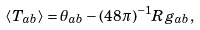<formula> <loc_0><loc_0><loc_500><loc_500>\langle T _ { a b } \rangle = \theta _ { a b } - ( 4 8 \pi ) ^ { - 1 } R g _ { a b } ,</formula> 